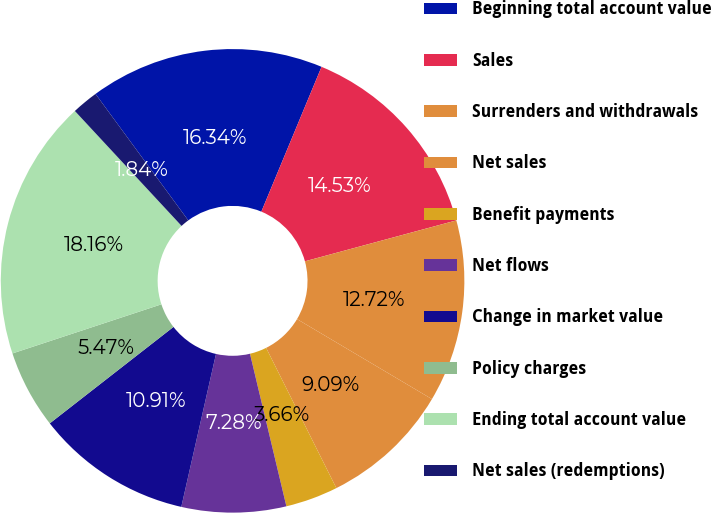Convert chart to OTSL. <chart><loc_0><loc_0><loc_500><loc_500><pie_chart><fcel>Beginning total account value<fcel>Sales<fcel>Surrenders and withdrawals<fcel>Net sales<fcel>Benefit payments<fcel>Net flows<fcel>Change in market value<fcel>Policy charges<fcel>Ending total account value<fcel>Net sales (redemptions)<nl><fcel>16.34%<fcel>14.53%<fcel>12.72%<fcel>9.09%<fcel>3.66%<fcel>7.28%<fcel>10.91%<fcel>5.47%<fcel>18.16%<fcel>1.84%<nl></chart> 